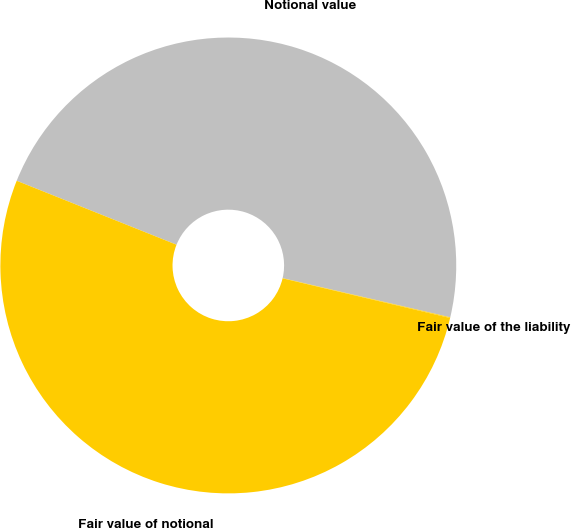Convert chart to OTSL. <chart><loc_0><loc_0><loc_500><loc_500><pie_chart><fcel>Notional value<fcel>Fair value of notional<fcel>Fair value of the liability<nl><fcel>47.59%<fcel>52.35%<fcel>0.05%<nl></chart> 